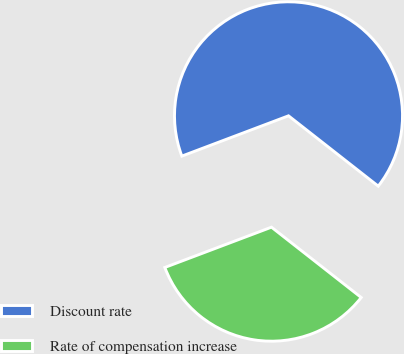Convert chart to OTSL. <chart><loc_0><loc_0><loc_500><loc_500><pie_chart><fcel>Discount rate<fcel>Rate of compensation increase<nl><fcel>66.33%<fcel>33.67%<nl></chart> 